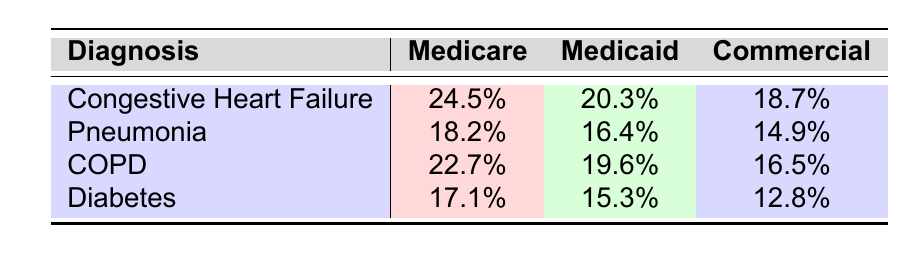What's the readmission rate for Congestive Heart Failure under Medicare? The table shows that the readmission rate for Congestive Heart Failure with Medicare is listed directly as 24.5%.
Answer: 24.5% Which diagnosis has the highest readmission rate for Medicaid? By comparing the readmission rates for Medicaid across all diagnoses in the table, Congestive Heart Failure has the highest rate at 20.3%.
Answer: Congestive Heart Failure What is the difference in readmission rates between COPD and Diabetes for Commercial insurance? The readmission rate for COPD is 16.5% and for Diabetes is 12.8%. The difference is calculated as 16.5% - 12.8% = 3.7%.
Answer: 3.7% Is the readmission rate for Pneumonia under Commercial insurance lower than that for Congestive Heart Failure under Medicare? The readmission rate for Pneumonia under Commercial insurance is 14.9%, while for Congestive Heart Failure under Medicare it is 24.5%. Since 14.9% is less than 24.5%, the statement is true.
Answer: Yes What is the average readmission rate for all diagnoses under Medicaid? Summing the readmission rates for Medicaid gives: 20.3% (CHF) + 16.4% (Pneumonia) + 19.6% (COPD) + 15.3% (Diabetes) = 71.6%. Dividing by 4 (the number of diagnoses), the average is 71.6% / 4 = 17.9%.
Answer: 17.9% Which diagnosis has the lowest readmission rate overall across all insurance types? Looking across the table, Diabetes has the lowest rates: 17.1% (Medicare), 15.3% (Medicaid), and 12.8% (Commercial). The lowest among these is 12.8% for Commercial.
Answer: Diabetes Is it true that readmission rates are consistently higher for Medicare compared to Medicaid across all diagnoses? In the table, Medicare rates are 24.5%, 18.2%, 22.7%, and 17.1% while Medicaid rates are 20.3%, 16.4%, 19.6%, and 15.3%. The Medicare rate is higher than the Medicaid rate for all diagnoses, confirming the statement is true.
Answer: Yes What is the total readmission rate for Congestive Heart Failure and COPD under Medicare? The readmission rates are 24.5% for Congestive Heart Failure and 22.7% for COPD. Adding these together, 24.5% + 22.7% = 47.2%.
Answer: 47.2% 